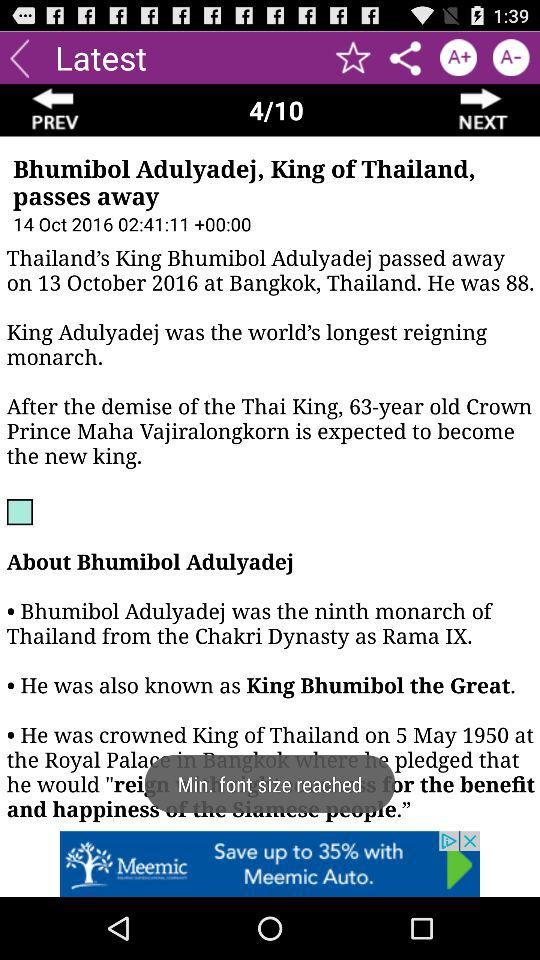How many years was King Adulyadej older than Crown Prince Maha Vajiralongkorn when he died?
Answer the question using a single word or phrase. 25 